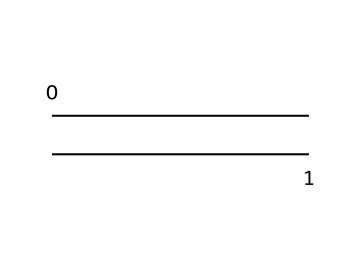What is the name of this monomer? The SMILES representation "C=C" indicates a molecule with a double bond between two carbon atoms, which is known as ethylene.
Answer: ethylene How many atoms are present in this chemical structure? The chemical structure contains 2 carbon atoms and no other atoms, leading to a total of 2 atoms.
Answer: 2 atoms How many bonds are present in the structure? The structure shows a double bond between the two carbon atoms, which counts as one bond. Therefore, there is 1 bond in the structure.
Answer: 1 bond What type of chemical is this? Ethylene is classified as an alkene due to the presence of a carbon-carbon double bond, a characteristic feature of alkenes.
Answer: alkene Is this monomer saturated or unsaturated? The presence of a double bond (C=C) indicates that ethylene is unsaturated, as saturated molecules only have single bonds.
Answer: unsaturated What is the degree of unsaturation in this compound? The degree of unsaturation corresponds to the number of multiple bonds or rings in the molecule; for ethylene, it has one double bond leading to a degree of unsaturation of 1.
Answer: 1 